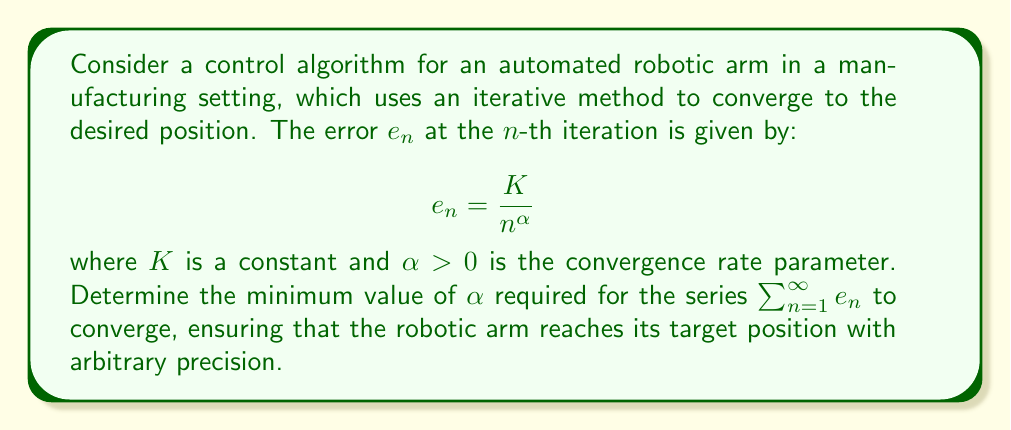What is the answer to this math problem? To determine the convergence of the series $\sum_{n=1}^{\infty} e_n$, we can use the p-series test. The general form of a p-series is:

$$ \sum_{n=1}^{\infty} \frac{1}{n^p} $$

Our series can be rewritten as:

$$ \sum_{n=1}^{\infty} e_n = \sum_{n=1}^{\infty} \frac{K}{n^{\alpha}} = K \sum_{n=1}^{\infty} \frac{1}{n^{\alpha}} $$

The p-series converges if and only if $p > 1$. In our case, $p = \alpha$.

Therefore, for the series to converge:

$$ \alpha > 1 $$

This means that the minimum value of $\alpha$ required for convergence is any value strictly greater than 1.

In the context of the robotic arm control, this implies that the error must decrease faster than $\frac{1}{n}$ for the arm to reach its target position with arbitrary precision. If $\alpha \leq 1$, the error would not decrease quickly enough, and the arm might oscillate or fail to reach the exact target position.
Answer: The minimum value of $\alpha$ required for convergence is any value strictly greater than 1, i.e., $\alpha > 1$. 